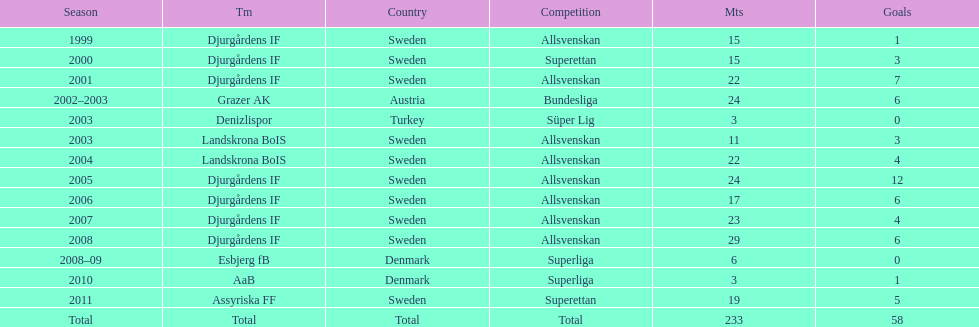How many matches overall were there? 233. 